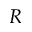Convert formula to latex. <formula><loc_0><loc_0><loc_500><loc_500>R</formula> 